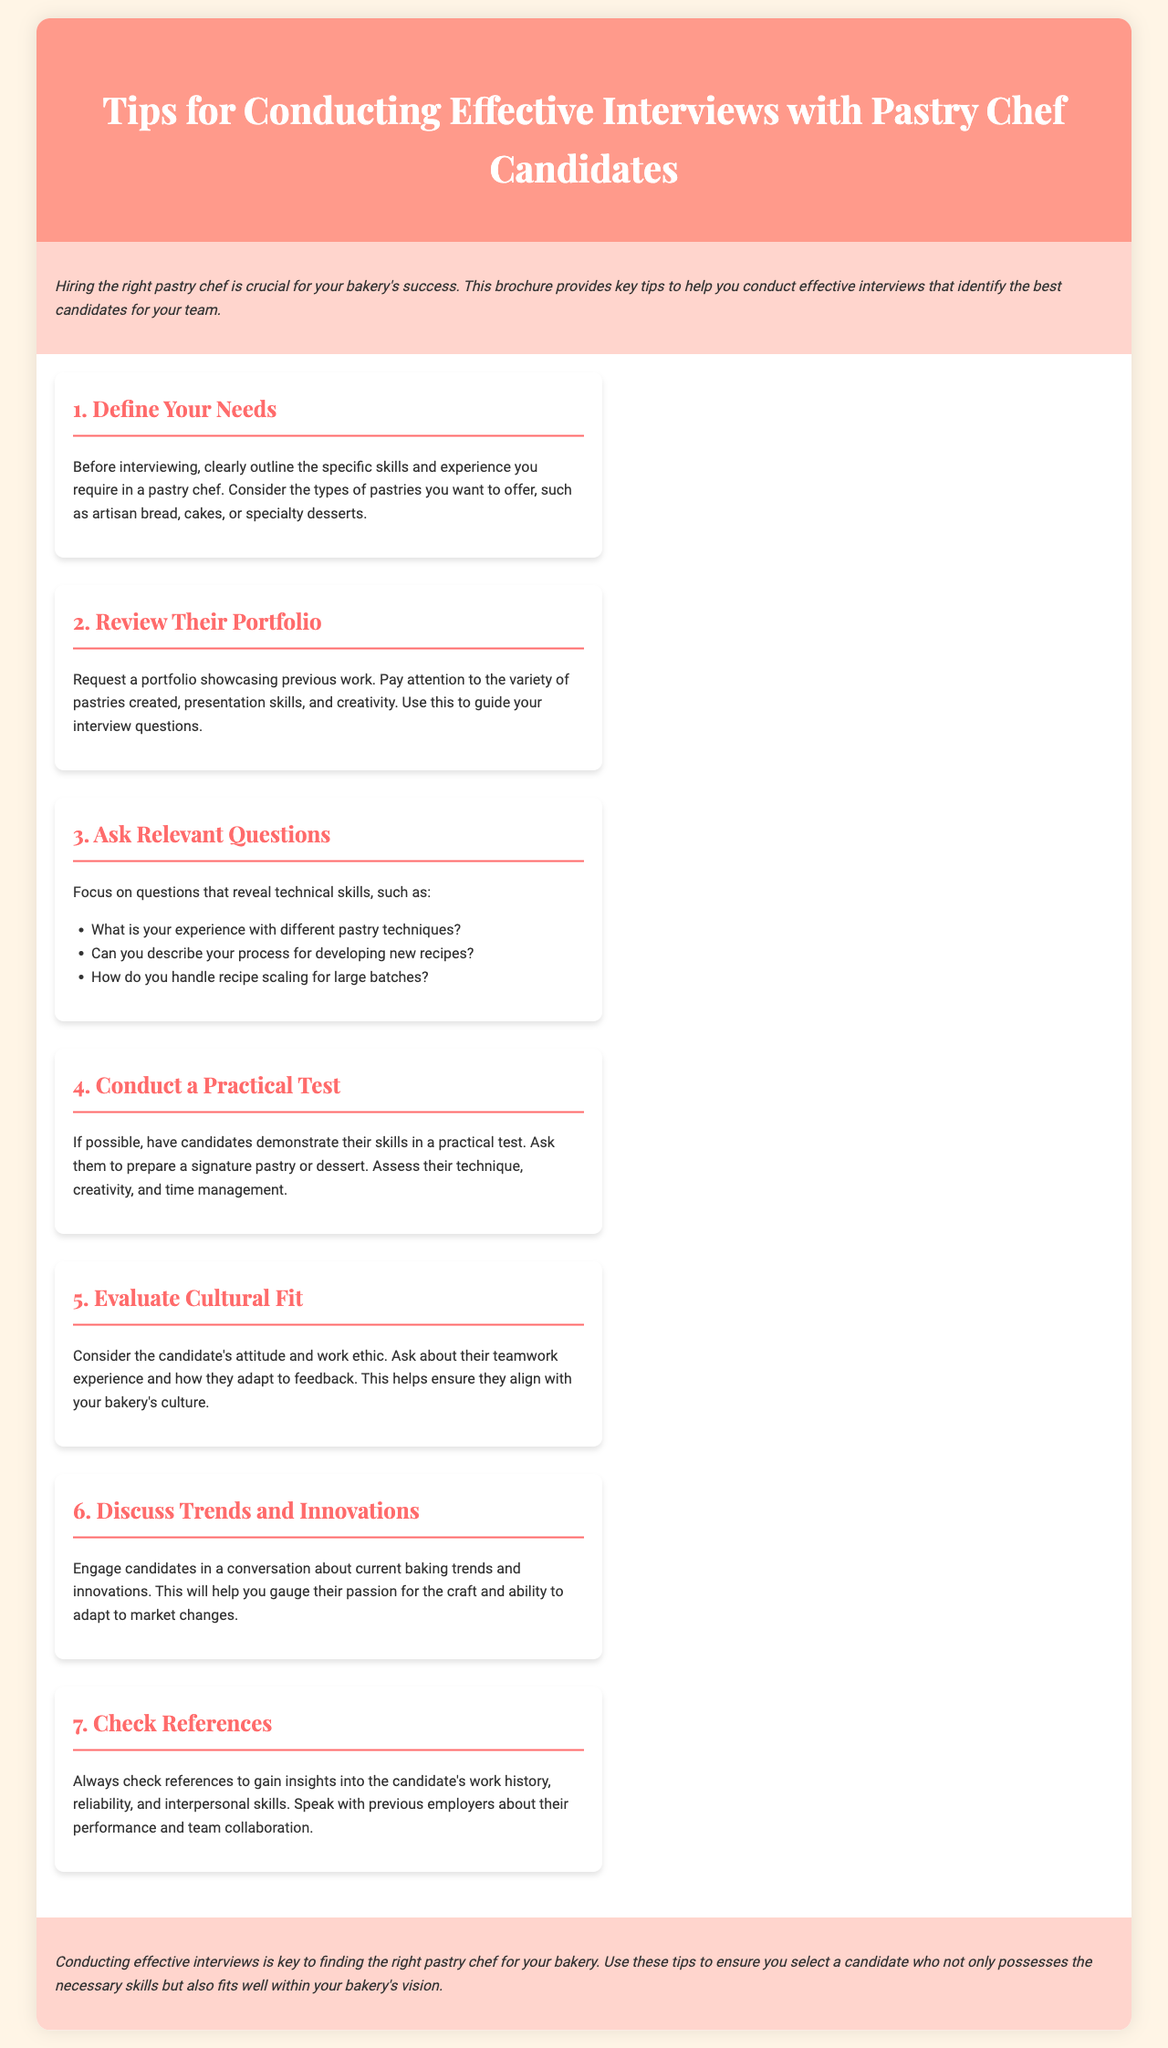what is the main purpose of the brochure? The brochure is created to provide key tips for conducting effective interviews that help identify the best candidates for your bakery team.
Answer: hiring the right pastry chef how many sections are in the content? The brochure contains seven distinct sections regarding interview tips.
Answer: 7 which section discusses evaluating cultural fit? The section dedicated to this topic is titled "Evaluate Cultural Fit."
Answer: Evaluate Cultural Fit what type of test does the brochure suggest conducting? The document recommends having candidates demonstrate their skills through a practical test.
Answer: practical test what should candidates showcase in their portfolio? The portfolio should highlight previous work, including a variety of pastries and presentation skills.
Answer: variety of pastries what is an important aspect to discuss regarding candidates? Engaging candidates in conversation about current baking trends and innovations is important.
Answer: trends and innovations which relevant question is suggested to ask about experience? The brochure suggests asking, "What is your experience with different pastry techniques?"
Answer: pastry techniques 